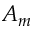<formula> <loc_0><loc_0><loc_500><loc_500>A _ { m }</formula> 